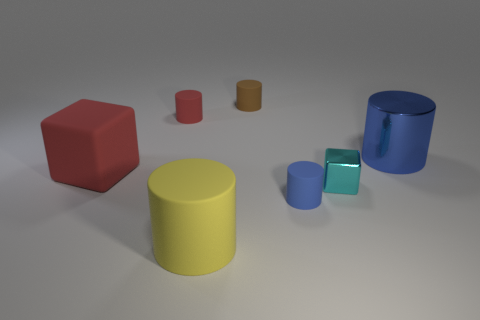What number of tiny red rubber cylinders are to the right of the small red thing that is behind the large rubber block?
Offer a terse response. 0. Are there any blue cylinders behind the brown matte cylinder?
Offer a terse response. No. The blue thing to the right of the metallic block that is on the right side of the yellow cylinder is what shape?
Ensure brevity in your answer.  Cylinder. Are there fewer small brown matte cylinders that are in front of the cyan thing than cubes that are in front of the big yellow cylinder?
Keep it short and to the point. No. There is another shiny thing that is the same shape as the brown thing; what color is it?
Ensure brevity in your answer.  Blue. How many cylinders are in front of the brown rubber thing and left of the shiny cylinder?
Offer a terse response. 3. Is the number of small shiny objects in front of the red cube greater than the number of tiny red things in front of the tiny blue cylinder?
Keep it short and to the point. Yes. The yellow rubber thing is what size?
Give a very brief answer. Large. Are there any other objects that have the same shape as the large red matte thing?
Offer a terse response. Yes. There is a tiny brown matte object; is its shape the same as the blue object in front of the big red rubber object?
Ensure brevity in your answer.  Yes. 